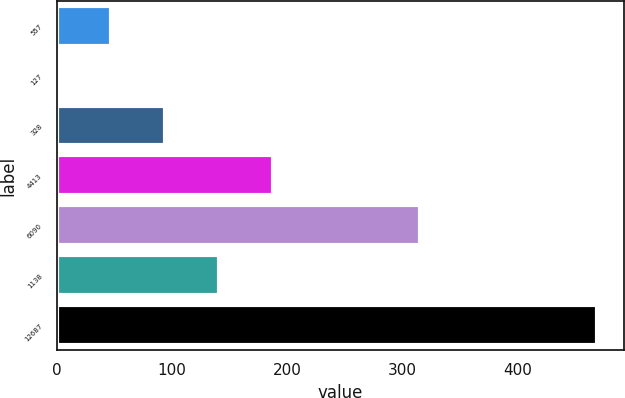<chart> <loc_0><loc_0><loc_500><loc_500><bar_chart><fcel>557<fcel>127<fcel>328<fcel>4413<fcel>6090<fcel>1138<fcel>12687<nl><fcel>47.03<fcel>0.2<fcel>93.86<fcel>187.52<fcel>314.8<fcel>140.69<fcel>468.5<nl></chart> 